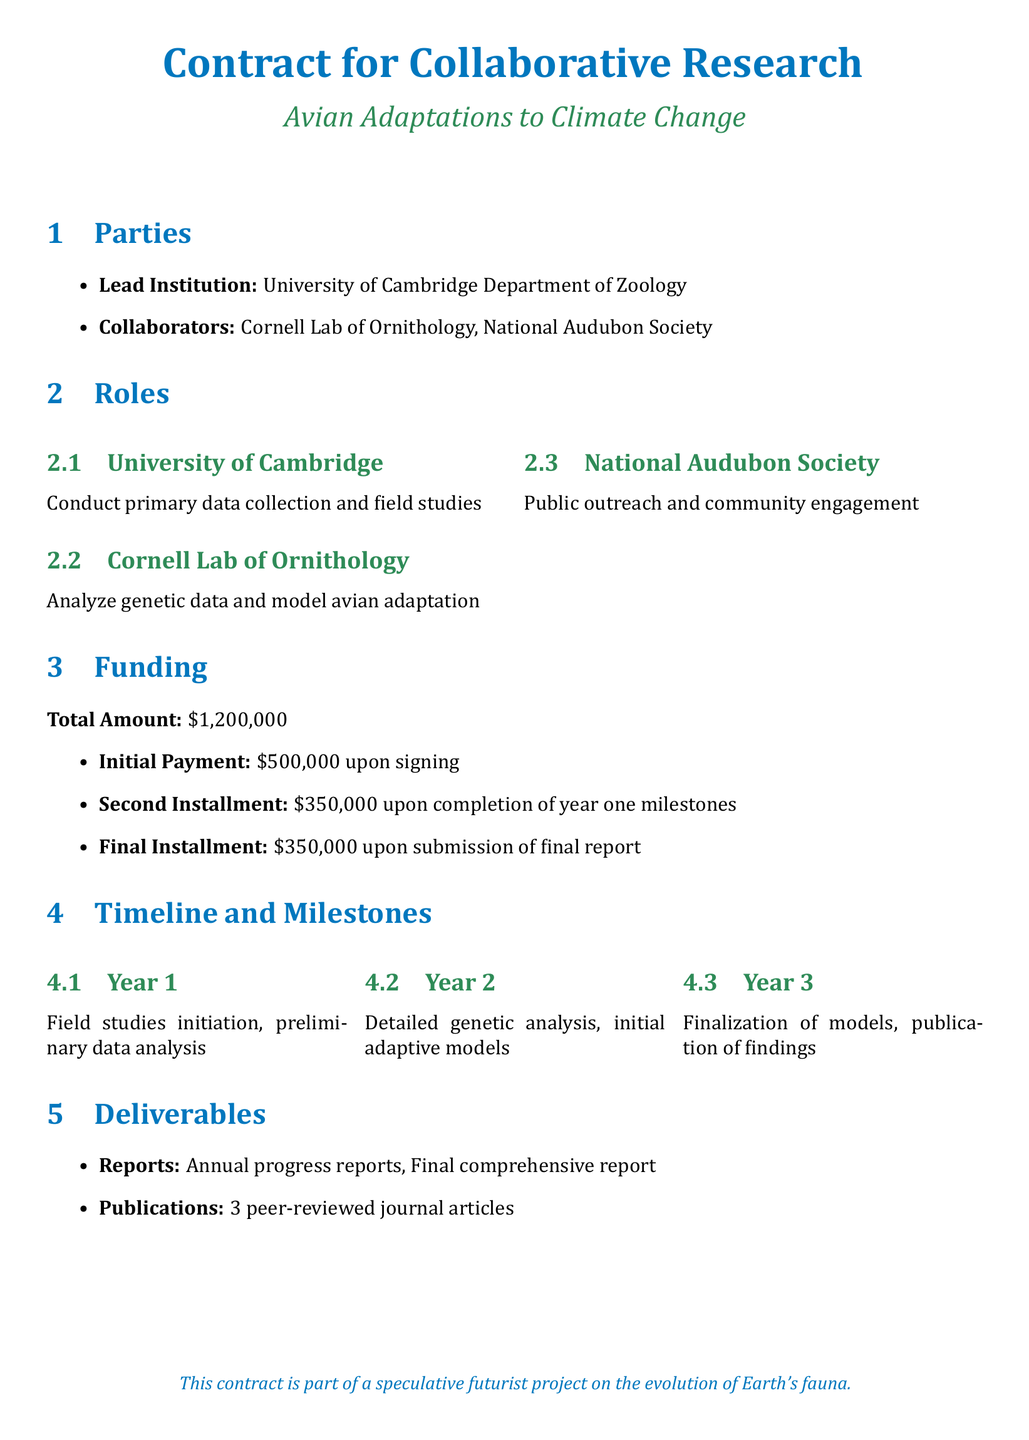What is the total funding amount? The total funding amount is specified in the Funding section of the contract.
Answer: $1,200,000 Who is the lead institution? The lead institution is mentioned in the Parties section of the contract.
Answer: University of Cambridge Department of Zoology What is the initial payment amount? The initial payment amount is listed under the Funding section, reflecting the first installment.
Answer: $500,000 Which institution is responsible for public outreach? The institution responsible for public outreach is detailed in the Roles section.
Answer: National Audubon Society How many peer-reviewed journal articles are expected? The expected number of peer-reviewed journal articles is stated in the Deliverables section.
Answer: 3 In which year are detailed genetic analyses expected to be completed? The expected year for completing detailed genetic analyses is indicated in the Timeline and Milestones section.
Answer: Year 2 What is the final payment amount? The final payment amount is named in the Funding section upon submission of the final report.
Answer: $350,000 What role does the Cornell Lab of Ornithology play? The role of the Cornell Lab of Ornithology is specified in the Roles section.
Answer: Analyze genetic data and model avian adaptation 